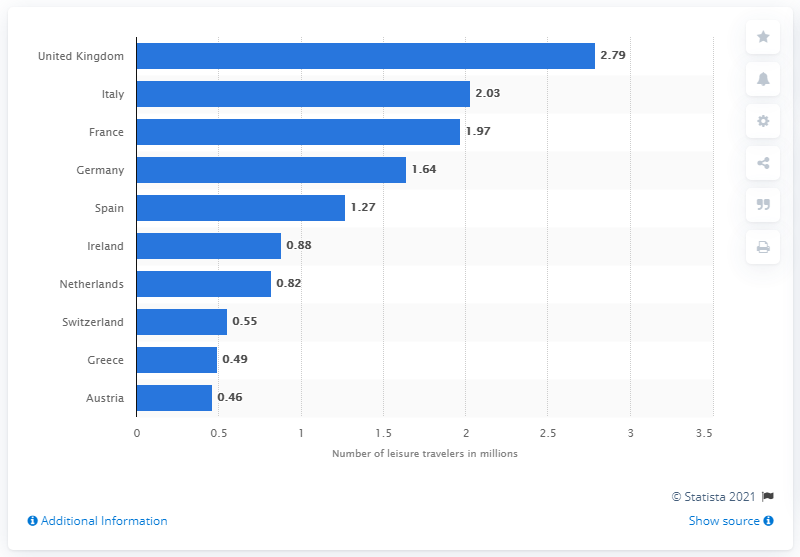Mention a couple of crucial points in this snapshot. In 2016, approximately 2.79 million leisure travelers from the United States visited the United Kingdom. 